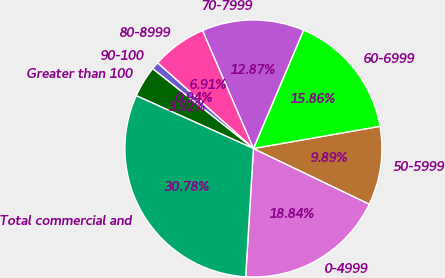<chart> <loc_0><loc_0><loc_500><loc_500><pie_chart><fcel>0-4999<fcel>50-5999<fcel>60-6999<fcel>70-7999<fcel>80-8999<fcel>90-100<fcel>Greater than 100<fcel>Total commercial and<nl><fcel>18.84%<fcel>9.89%<fcel>15.86%<fcel>12.87%<fcel>6.91%<fcel>0.94%<fcel>3.92%<fcel>30.78%<nl></chart> 